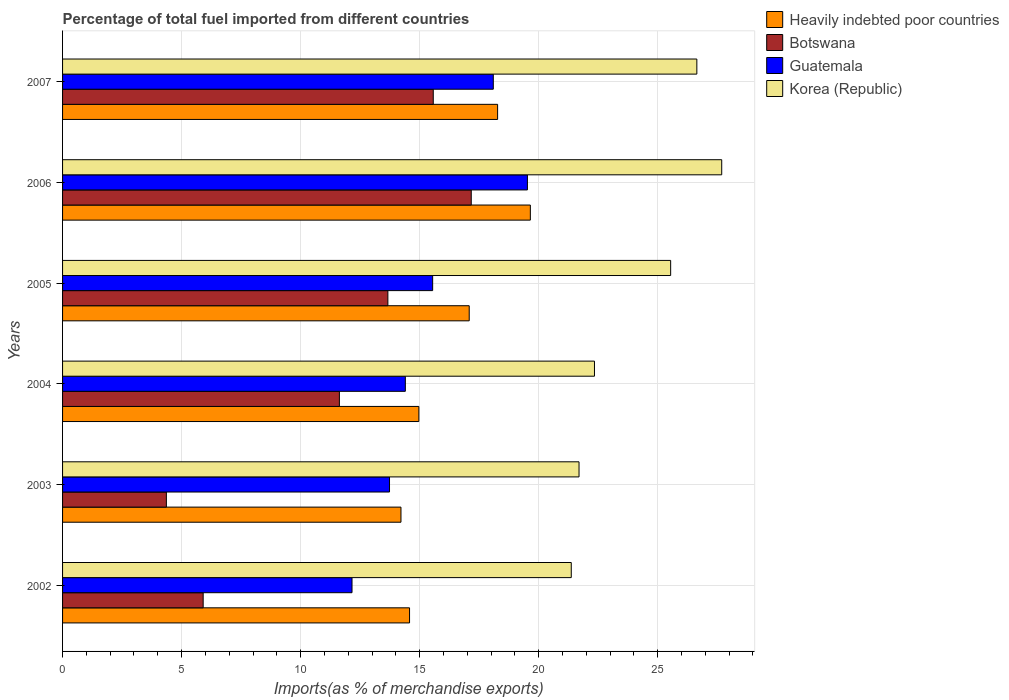Are the number of bars on each tick of the Y-axis equal?
Offer a terse response. Yes. How many bars are there on the 4th tick from the top?
Ensure brevity in your answer.  4. How many bars are there on the 3rd tick from the bottom?
Provide a succinct answer. 4. In how many cases, is the number of bars for a given year not equal to the number of legend labels?
Your response must be concise. 0. What is the percentage of imports to different countries in Guatemala in 2003?
Your response must be concise. 13.73. Across all years, what is the maximum percentage of imports to different countries in Heavily indebted poor countries?
Offer a terse response. 19.65. Across all years, what is the minimum percentage of imports to different countries in Korea (Republic)?
Offer a very short reply. 21.37. In which year was the percentage of imports to different countries in Guatemala maximum?
Provide a succinct answer. 2006. What is the total percentage of imports to different countries in Botswana in the graph?
Ensure brevity in your answer.  68.3. What is the difference between the percentage of imports to different countries in Korea (Republic) in 2002 and that in 2003?
Offer a terse response. -0.33. What is the difference between the percentage of imports to different countries in Botswana in 2005 and the percentage of imports to different countries in Korea (Republic) in 2007?
Offer a very short reply. -12.98. What is the average percentage of imports to different countries in Heavily indebted poor countries per year?
Keep it short and to the point. 16.46. In the year 2006, what is the difference between the percentage of imports to different countries in Korea (Republic) and percentage of imports to different countries in Guatemala?
Your response must be concise. 8.16. What is the ratio of the percentage of imports to different countries in Korea (Republic) in 2004 to that in 2005?
Provide a succinct answer. 0.87. What is the difference between the highest and the second highest percentage of imports to different countries in Guatemala?
Ensure brevity in your answer.  1.43. What is the difference between the highest and the lowest percentage of imports to different countries in Heavily indebted poor countries?
Your response must be concise. 5.44. In how many years, is the percentage of imports to different countries in Botswana greater than the average percentage of imports to different countries in Botswana taken over all years?
Your answer should be very brief. 4. Is the sum of the percentage of imports to different countries in Korea (Republic) in 2003 and 2006 greater than the maximum percentage of imports to different countries in Guatemala across all years?
Your answer should be compact. Yes. Is it the case that in every year, the sum of the percentage of imports to different countries in Guatemala and percentage of imports to different countries in Botswana is greater than the sum of percentage of imports to different countries in Korea (Republic) and percentage of imports to different countries in Heavily indebted poor countries?
Your answer should be compact. No. What does the 4th bar from the top in 2003 represents?
Provide a short and direct response. Heavily indebted poor countries. What does the 2nd bar from the bottom in 2006 represents?
Your answer should be compact. Botswana. Is it the case that in every year, the sum of the percentage of imports to different countries in Korea (Republic) and percentage of imports to different countries in Guatemala is greater than the percentage of imports to different countries in Heavily indebted poor countries?
Provide a succinct answer. Yes. How many bars are there?
Give a very brief answer. 24. How many years are there in the graph?
Offer a very short reply. 6. What is the difference between two consecutive major ticks on the X-axis?
Your answer should be very brief. 5. Are the values on the major ticks of X-axis written in scientific E-notation?
Your answer should be compact. No. Does the graph contain any zero values?
Make the answer very short. No. Does the graph contain grids?
Offer a very short reply. Yes. Where does the legend appear in the graph?
Keep it short and to the point. Top right. How many legend labels are there?
Your answer should be very brief. 4. How are the legend labels stacked?
Your answer should be compact. Vertical. What is the title of the graph?
Ensure brevity in your answer.  Percentage of total fuel imported from different countries. What is the label or title of the X-axis?
Your response must be concise. Imports(as % of merchandise exports). What is the Imports(as % of merchandise exports) in Heavily indebted poor countries in 2002?
Your answer should be compact. 14.58. What is the Imports(as % of merchandise exports) of Botswana in 2002?
Your answer should be very brief. 5.91. What is the Imports(as % of merchandise exports) in Guatemala in 2002?
Provide a succinct answer. 12.16. What is the Imports(as % of merchandise exports) in Korea (Republic) in 2002?
Ensure brevity in your answer.  21.37. What is the Imports(as % of merchandise exports) of Heavily indebted poor countries in 2003?
Offer a terse response. 14.21. What is the Imports(as % of merchandise exports) in Botswana in 2003?
Provide a short and direct response. 4.36. What is the Imports(as % of merchandise exports) in Guatemala in 2003?
Your answer should be very brief. 13.73. What is the Imports(as % of merchandise exports) in Korea (Republic) in 2003?
Your answer should be very brief. 21.69. What is the Imports(as % of merchandise exports) in Heavily indebted poor countries in 2004?
Your response must be concise. 14.97. What is the Imports(as % of merchandise exports) of Botswana in 2004?
Provide a succinct answer. 11.63. What is the Imports(as % of merchandise exports) in Guatemala in 2004?
Keep it short and to the point. 14.4. What is the Imports(as % of merchandise exports) in Korea (Republic) in 2004?
Offer a terse response. 22.34. What is the Imports(as % of merchandise exports) in Heavily indebted poor countries in 2005?
Provide a succinct answer. 17.08. What is the Imports(as % of merchandise exports) of Botswana in 2005?
Offer a very short reply. 13.66. What is the Imports(as % of merchandise exports) in Guatemala in 2005?
Your answer should be very brief. 15.55. What is the Imports(as % of merchandise exports) of Korea (Republic) in 2005?
Keep it short and to the point. 25.54. What is the Imports(as % of merchandise exports) in Heavily indebted poor countries in 2006?
Your answer should be very brief. 19.65. What is the Imports(as % of merchandise exports) in Botswana in 2006?
Provide a succinct answer. 17.17. What is the Imports(as % of merchandise exports) of Guatemala in 2006?
Give a very brief answer. 19.53. What is the Imports(as % of merchandise exports) in Korea (Republic) in 2006?
Your answer should be very brief. 27.69. What is the Imports(as % of merchandise exports) of Heavily indebted poor countries in 2007?
Offer a terse response. 18.27. What is the Imports(as % of merchandise exports) of Botswana in 2007?
Your response must be concise. 15.57. What is the Imports(as % of merchandise exports) in Guatemala in 2007?
Make the answer very short. 18.09. What is the Imports(as % of merchandise exports) in Korea (Republic) in 2007?
Provide a short and direct response. 26.64. Across all years, what is the maximum Imports(as % of merchandise exports) of Heavily indebted poor countries?
Provide a succinct answer. 19.65. Across all years, what is the maximum Imports(as % of merchandise exports) of Botswana?
Your response must be concise. 17.17. Across all years, what is the maximum Imports(as % of merchandise exports) of Guatemala?
Offer a very short reply. 19.53. Across all years, what is the maximum Imports(as % of merchandise exports) in Korea (Republic)?
Provide a succinct answer. 27.69. Across all years, what is the minimum Imports(as % of merchandise exports) of Heavily indebted poor countries?
Keep it short and to the point. 14.21. Across all years, what is the minimum Imports(as % of merchandise exports) of Botswana?
Give a very brief answer. 4.36. Across all years, what is the minimum Imports(as % of merchandise exports) in Guatemala?
Provide a short and direct response. 12.16. Across all years, what is the minimum Imports(as % of merchandise exports) in Korea (Republic)?
Your answer should be very brief. 21.37. What is the total Imports(as % of merchandise exports) in Heavily indebted poor countries in the graph?
Make the answer very short. 98.76. What is the total Imports(as % of merchandise exports) of Botswana in the graph?
Offer a terse response. 68.3. What is the total Imports(as % of merchandise exports) in Guatemala in the graph?
Offer a very short reply. 93.46. What is the total Imports(as % of merchandise exports) of Korea (Republic) in the graph?
Provide a short and direct response. 145.28. What is the difference between the Imports(as % of merchandise exports) in Heavily indebted poor countries in 2002 and that in 2003?
Provide a succinct answer. 0.36. What is the difference between the Imports(as % of merchandise exports) of Botswana in 2002 and that in 2003?
Provide a short and direct response. 1.55. What is the difference between the Imports(as % of merchandise exports) of Guatemala in 2002 and that in 2003?
Keep it short and to the point. -1.58. What is the difference between the Imports(as % of merchandise exports) of Korea (Republic) in 2002 and that in 2003?
Give a very brief answer. -0.33. What is the difference between the Imports(as % of merchandise exports) in Heavily indebted poor countries in 2002 and that in 2004?
Provide a short and direct response. -0.39. What is the difference between the Imports(as % of merchandise exports) of Botswana in 2002 and that in 2004?
Provide a short and direct response. -5.72. What is the difference between the Imports(as % of merchandise exports) in Guatemala in 2002 and that in 2004?
Your answer should be very brief. -2.24. What is the difference between the Imports(as % of merchandise exports) in Korea (Republic) in 2002 and that in 2004?
Your response must be concise. -0.97. What is the difference between the Imports(as % of merchandise exports) in Heavily indebted poor countries in 2002 and that in 2005?
Keep it short and to the point. -2.51. What is the difference between the Imports(as % of merchandise exports) of Botswana in 2002 and that in 2005?
Provide a succinct answer. -7.76. What is the difference between the Imports(as % of merchandise exports) in Guatemala in 2002 and that in 2005?
Give a very brief answer. -3.39. What is the difference between the Imports(as % of merchandise exports) in Korea (Republic) in 2002 and that in 2005?
Provide a succinct answer. -4.17. What is the difference between the Imports(as % of merchandise exports) in Heavily indebted poor countries in 2002 and that in 2006?
Offer a terse response. -5.07. What is the difference between the Imports(as % of merchandise exports) of Botswana in 2002 and that in 2006?
Your response must be concise. -11.26. What is the difference between the Imports(as % of merchandise exports) in Guatemala in 2002 and that in 2006?
Keep it short and to the point. -7.37. What is the difference between the Imports(as % of merchandise exports) of Korea (Republic) in 2002 and that in 2006?
Keep it short and to the point. -6.32. What is the difference between the Imports(as % of merchandise exports) of Heavily indebted poor countries in 2002 and that in 2007?
Ensure brevity in your answer.  -3.7. What is the difference between the Imports(as % of merchandise exports) in Botswana in 2002 and that in 2007?
Provide a short and direct response. -9.67. What is the difference between the Imports(as % of merchandise exports) in Guatemala in 2002 and that in 2007?
Give a very brief answer. -5.93. What is the difference between the Imports(as % of merchandise exports) of Korea (Republic) in 2002 and that in 2007?
Provide a short and direct response. -5.28. What is the difference between the Imports(as % of merchandise exports) of Heavily indebted poor countries in 2003 and that in 2004?
Your response must be concise. -0.75. What is the difference between the Imports(as % of merchandise exports) in Botswana in 2003 and that in 2004?
Make the answer very short. -7.27. What is the difference between the Imports(as % of merchandise exports) in Guatemala in 2003 and that in 2004?
Make the answer very short. -0.66. What is the difference between the Imports(as % of merchandise exports) of Korea (Republic) in 2003 and that in 2004?
Offer a very short reply. -0.65. What is the difference between the Imports(as % of merchandise exports) of Heavily indebted poor countries in 2003 and that in 2005?
Give a very brief answer. -2.87. What is the difference between the Imports(as % of merchandise exports) of Botswana in 2003 and that in 2005?
Provide a succinct answer. -9.3. What is the difference between the Imports(as % of merchandise exports) in Guatemala in 2003 and that in 2005?
Keep it short and to the point. -1.81. What is the difference between the Imports(as % of merchandise exports) in Korea (Republic) in 2003 and that in 2005?
Give a very brief answer. -3.85. What is the difference between the Imports(as % of merchandise exports) of Heavily indebted poor countries in 2003 and that in 2006?
Ensure brevity in your answer.  -5.43. What is the difference between the Imports(as % of merchandise exports) in Botswana in 2003 and that in 2006?
Offer a very short reply. -12.81. What is the difference between the Imports(as % of merchandise exports) in Guatemala in 2003 and that in 2006?
Provide a succinct answer. -5.79. What is the difference between the Imports(as % of merchandise exports) in Korea (Republic) in 2003 and that in 2006?
Your answer should be compact. -5.99. What is the difference between the Imports(as % of merchandise exports) of Heavily indebted poor countries in 2003 and that in 2007?
Offer a very short reply. -4.06. What is the difference between the Imports(as % of merchandise exports) of Botswana in 2003 and that in 2007?
Give a very brief answer. -11.21. What is the difference between the Imports(as % of merchandise exports) in Guatemala in 2003 and that in 2007?
Your answer should be very brief. -4.36. What is the difference between the Imports(as % of merchandise exports) of Korea (Republic) in 2003 and that in 2007?
Make the answer very short. -4.95. What is the difference between the Imports(as % of merchandise exports) of Heavily indebted poor countries in 2004 and that in 2005?
Offer a very short reply. -2.12. What is the difference between the Imports(as % of merchandise exports) of Botswana in 2004 and that in 2005?
Your answer should be compact. -2.04. What is the difference between the Imports(as % of merchandise exports) of Guatemala in 2004 and that in 2005?
Make the answer very short. -1.15. What is the difference between the Imports(as % of merchandise exports) in Korea (Republic) in 2004 and that in 2005?
Offer a very short reply. -3.2. What is the difference between the Imports(as % of merchandise exports) in Heavily indebted poor countries in 2004 and that in 2006?
Provide a succinct answer. -4.68. What is the difference between the Imports(as % of merchandise exports) of Botswana in 2004 and that in 2006?
Provide a short and direct response. -5.54. What is the difference between the Imports(as % of merchandise exports) in Guatemala in 2004 and that in 2006?
Offer a very short reply. -5.13. What is the difference between the Imports(as % of merchandise exports) in Korea (Republic) in 2004 and that in 2006?
Your answer should be very brief. -5.35. What is the difference between the Imports(as % of merchandise exports) in Heavily indebted poor countries in 2004 and that in 2007?
Offer a terse response. -3.31. What is the difference between the Imports(as % of merchandise exports) in Botswana in 2004 and that in 2007?
Provide a short and direct response. -3.94. What is the difference between the Imports(as % of merchandise exports) of Guatemala in 2004 and that in 2007?
Your response must be concise. -3.69. What is the difference between the Imports(as % of merchandise exports) in Korea (Republic) in 2004 and that in 2007?
Give a very brief answer. -4.3. What is the difference between the Imports(as % of merchandise exports) in Heavily indebted poor countries in 2005 and that in 2006?
Provide a succinct answer. -2.57. What is the difference between the Imports(as % of merchandise exports) in Botswana in 2005 and that in 2006?
Make the answer very short. -3.5. What is the difference between the Imports(as % of merchandise exports) of Guatemala in 2005 and that in 2006?
Your answer should be very brief. -3.98. What is the difference between the Imports(as % of merchandise exports) of Korea (Republic) in 2005 and that in 2006?
Your answer should be very brief. -2.15. What is the difference between the Imports(as % of merchandise exports) in Heavily indebted poor countries in 2005 and that in 2007?
Provide a short and direct response. -1.19. What is the difference between the Imports(as % of merchandise exports) of Botswana in 2005 and that in 2007?
Your response must be concise. -1.91. What is the difference between the Imports(as % of merchandise exports) of Guatemala in 2005 and that in 2007?
Your response must be concise. -2.55. What is the difference between the Imports(as % of merchandise exports) of Korea (Republic) in 2005 and that in 2007?
Ensure brevity in your answer.  -1.1. What is the difference between the Imports(as % of merchandise exports) of Heavily indebted poor countries in 2006 and that in 2007?
Your answer should be very brief. 1.38. What is the difference between the Imports(as % of merchandise exports) of Botswana in 2006 and that in 2007?
Offer a terse response. 1.6. What is the difference between the Imports(as % of merchandise exports) in Guatemala in 2006 and that in 2007?
Your answer should be compact. 1.43. What is the difference between the Imports(as % of merchandise exports) of Korea (Republic) in 2006 and that in 2007?
Ensure brevity in your answer.  1.04. What is the difference between the Imports(as % of merchandise exports) in Heavily indebted poor countries in 2002 and the Imports(as % of merchandise exports) in Botswana in 2003?
Your response must be concise. 10.21. What is the difference between the Imports(as % of merchandise exports) of Heavily indebted poor countries in 2002 and the Imports(as % of merchandise exports) of Guatemala in 2003?
Ensure brevity in your answer.  0.84. What is the difference between the Imports(as % of merchandise exports) in Heavily indebted poor countries in 2002 and the Imports(as % of merchandise exports) in Korea (Republic) in 2003?
Offer a terse response. -7.12. What is the difference between the Imports(as % of merchandise exports) in Botswana in 2002 and the Imports(as % of merchandise exports) in Guatemala in 2003?
Provide a succinct answer. -7.83. What is the difference between the Imports(as % of merchandise exports) in Botswana in 2002 and the Imports(as % of merchandise exports) in Korea (Republic) in 2003?
Offer a very short reply. -15.79. What is the difference between the Imports(as % of merchandise exports) in Guatemala in 2002 and the Imports(as % of merchandise exports) in Korea (Republic) in 2003?
Offer a very short reply. -9.54. What is the difference between the Imports(as % of merchandise exports) in Heavily indebted poor countries in 2002 and the Imports(as % of merchandise exports) in Botswana in 2004?
Offer a very short reply. 2.95. What is the difference between the Imports(as % of merchandise exports) of Heavily indebted poor countries in 2002 and the Imports(as % of merchandise exports) of Guatemala in 2004?
Your response must be concise. 0.18. What is the difference between the Imports(as % of merchandise exports) in Heavily indebted poor countries in 2002 and the Imports(as % of merchandise exports) in Korea (Republic) in 2004?
Provide a succinct answer. -7.77. What is the difference between the Imports(as % of merchandise exports) of Botswana in 2002 and the Imports(as % of merchandise exports) of Guatemala in 2004?
Offer a terse response. -8.49. What is the difference between the Imports(as % of merchandise exports) of Botswana in 2002 and the Imports(as % of merchandise exports) of Korea (Republic) in 2004?
Give a very brief answer. -16.44. What is the difference between the Imports(as % of merchandise exports) in Guatemala in 2002 and the Imports(as % of merchandise exports) in Korea (Republic) in 2004?
Provide a succinct answer. -10.18. What is the difference between the Imports(as % of merchandise exports) in Heavily indebted poor countries in 2002 and the Imports(as % of merchandise exports) in Botswana in 2005?
Keep it short and to the point. 0.91. What is the difference between the Imports(as % of merchandise exports) of Heavily indebted poor countries in 2002 and the Imports(as % of merchandise exports) of Guatemala in 2005?
Give a very brief answer. -0.97. What is the difference between the Imports(as % of merchandise exports) in Heavily indebted poor countries in 2002 and the Imports(as % of merchandise exports) in Korea (Republic) in 2005?
Provide a short and direct response. -10.97. What is the difference between the Imports(as % of merchandise exports) of Botswana in 2002 and the Imports(as % of merchandise exports) of Guatemala in 2005?
Your answer should be compact. -9.64. What is the difference between the Imports(as % of merchandise exports) of Botswana in 2002 and the Imports(as % of merchandise exports) of Korea (Republic) in 2005?
Provide a succinct answer. -19.64. What is the difference between the Imports(as % of merchandise exports) in Guatemala in 2002 and the Imports(as % of merchandise exports) in Korea (Republic) in 2005?
Provide a short and direct response. -13.38. What is the difference between the Imports(as % of merchandise exports) of Heavily indebted poor countries in 2002 and the Imports(as % of merchandise exports) of Botswana in 2006?
Your answer should be compact. -2.59. What is the difference between the Imports(as % of merchandise exports) in Heavily indebted poor countries in 2002 and the Imports(as % of merchandise exports) in Guatemala in 2006?
Make the answer very short. -4.95. What is the difference between the Imports(as % of merchandise exports) of Heavily indebted poor countries in 2002 and the Imports(as % of merchandise exports) of Korea (Republic) in 2006?
Your answer should be very brief. -13.11. What is the difference between the Imports(as % of merchandise exports) in Botswana in 2002 and the Imports(as % of merchandise exports) in Guatemala in 2006?
Your response must be concise. -13.62. What is the difference between the Imports(as % of merchandise exports) in Botswana in 2002 and the Imports(as % of merchandise exports) in Korea (Republic) in 2006?
Offer a terse response. -21.78. What is the difference between the Imports(as % of merchandise exports) in Guatemala in 2002 and the Imports(as % of merchandise exports) in Korea (Republic) in 2006?
Provide a short and direct response. -15.53. What is the difference between the Imports(as % of merchandise exports) of Heavily indebted poor countries in 2002 and the Imports(as % of merchandise exports) of Botswana in 2007?
Your answer should be compact. -1. What is the difference between the Imports(as % of merchandise exports) in Heavily indebted poor countries in 2002 and the Imports(as % of merchandise exports) in Guatemala in 2007?
Make the answer very short. -3.52. What is the difference between the Imports(as % of merchandise exports) in Heavily indebted poor countries in 2002 and the Imports(as % of merchandise exports) in Korea (Republic) in 2007?
Offer a terse response. -12.07. What is the difference between the Imports(as % of merchandise exports) of Botswana in 2002 and the Imports(as % of merchandise exports) of Guatemala in 2007?
Offer a terse response. -12.19. What is the difference between the Imports(as % of merchandise exports) of Botswana in 2002 and the Imports(as % of merchandise exports) of Korea (Republic) in 2007?
Provide a short and direct response. -20.74. What is the difference between the Imports(as % of merchandise exports) of Guatemala in 2002 and the Imports(as % of merchandise exports) of Korea (Republic) in 2007?
Your response must be concise. -14.49. What is the difference between the Imports(as % of merchandise exports) in Heavily indebted poor countries in 2003 and the Imports(as % of merchandise exports) in Botswana in 2004?
Offer a terse response. 2.59. What is the difference between the Imports(as % of merchandise exports) in Heavily indebted poor countries in 2003 and the Imports(as % of merchandise exports) in Guatemala in 2004?
Your answer should be compact. -0.18. What is the difference between the Imports(as % of merchandise exports) in Heavily indebted poor countries in 2003 and the Imports(as % of merchandise exports) in Korea (Republic) in 2004?
Give a very brief answer. -8.13. What is the difference between the Imports(as % of merchandise exports) in Botswana in 2003 and the Imports(as % of merchandise exports) in Guatemala in 2004?
Give a very brief answer. -10.04. What is the difference between the Imports(as % of merchandise exports) of Botswana in 2003 and the Imports(as % of merchandise exports) of Korea (Republic) in 2004?
Offer a terse response. -17.98. What is the difference between the Imports(as % of merchandise exports) of Guatemala in 2003 and the Imports(as % of merchandise exports) of Korea (Republic) in 2004?
Your answer should be compact. -8.61. What is the difference between the Imports(as % of merchandise exports) of Heavily indebted poor countries in 2003 and the Imports(as % of merchandise exports) of Botswana in 2005?
Keep it short and to the point. 0.55. What is the difference between the Imports(as % of merchandise exports) in Heavily indebted poor countries in 2003 and the Imports(as % of merchandise exports) in Guatemala in 2005?
Offer a very short reply. -1.33. What is the difference between the Imports(as % of merchandise exports) of Heavily indebted poor countries in 2003 and the Imports(as % of merchandise exports) of Korea (Republic) in 2005?
Provide a succinct answer. -11.33. What is the difference between the Imports(as % of merchandise exports) of Botswana in 2003 and the Imports(as % of merchandise exports) of Guatemala in 2005?
Offer a terse response. -11.19. What is the difference between the Imports(as % of merchandise exports) of Botswana in 2003 and the Imports(as % of merchandise exports) of Korea (Republic) in 2005?
Provide a short and direct response. -21.18. What is the difference between the Imports(as % of merchandise exports) in Guatemala in 2003 and the Imports(as % of merchandise exports) in Korea (Republic) in 2005?
Provide a succinct answer. -11.81. What is the difference between the Imports(as % of merchandise exports) in Heavily indebted poor countries in 2003 and the Imports(as % of merchandise exports) in Botswana in 2006?
Make the answer very short. -2.95. What is the difference between the Imports(as % of merchandise exports) in Heavily indebted poor countries in 2003 and the Imports(as % of merchandise exports) in Guatemala in 2006?
Provide a short and direct response. -5.31. What is the difference between the Imports(as % of merchandise exports) of Heavily indebted poor countries in 2003 and the Imports(as % of merchandise exports) of Korea (Republic) in 2006?
Offer a terse response. -13.47. What is the difference between the Imports(as % of merchandise exports) of Botswana in 2003 and the Imports(as % of merchandise exports) of Guatemala in 2006?
Offer a terse response. -15.17. What is the difference between the Imports(as % of merchandise exports) of Botswana in 2003 and the Imports(as % of merchandise exports) of Korea (Republic) in 2006?
Provide a succinct answer. -23.33. What is the difference between the Imports(as % of merchandise exports) of Guatemala in 2003 and the Imports(as % of merchandise exports) of Korea (Republic) in 2006?
Your response must be concise. -13.95. What is the difference between the Imports(as % of merchandise exports) of Heavily indebted poor countries in 2003 and the Imports(as % of merchandise exports) of Botswana in 2007?
Your answer should be compact. -1.36. What is the difference between the Imports(as % of merchandise exports) of Heavily indebted poor countries in 2003 and the Imports(as % of merchandise exports) of Guatemala in 2007?
Your answer should be compact. -3.88. What is the difference between the Imports(as % of merchandise exports) of Heavily indebted poor countries in 2003 and the Imports(as % of merchandise exports) of Korea (Republic) in 2007?
Your response must be concise. -12.43. What is the difference between the Imports(as % of merchandise exports) in Botswana in 2003 and the Imports(as % of merchandise exports) in Guatemala in 2007?
Provide a short and direct response. -13.73. What is the difference between the Imports(as % of merchandise exports) in Botswana in 2003 and the Imports(as % of merchandise exports) in Korea (Republic) in 2007?
Keep it short and to the point. -22.28. What is the difference between the Imports(as % of merchandise exports) in Guatemala in 2003 and the Imports(as % of merchandise exports) in Korea (Republic) in 2007?
Offer a terse response. -12.91. What is the difference between the Imports(as % of merchandise exports) in Heavily indebted poor countries in 2004 and the Imports(as % of merchandise exports) in Botswana in 2005?
Your answer should be compact. 1.3. What is the difference between the Imports(as % of merchandise exports) of Heavily indebted poor countries in 2004 and the Imports(as % of merchandise exports) of Guatemala in 2005?
Offer a terse response. -0.58. What is the difference between the Imports(as % of merchandise exports) in Heavily indebted poor countries in 2004 and the Imports(as % of merchandise exports) in Korea (Republic) in 2005?
Provide a short and direct response. -10.58. What is the difference between the Imports(as % of merchandise exports) in Botswana in 2004 and the Imports(as % of merchandise exports) in Guatemala in 2005?
Your response must be concise. -3.92. What is the difference between the Imports(as % of merchandise exports) in Botswana in 2004 and the Imports(as % of merchandise exports) in Korea (Republic) in 2005?
Offer a very short reply. -13.91. What is the difference between the Imports(as % of merchandise exports) of Guatemala in 2004 and the Imports(as % of merchandise exports) of Korea (Republic) in 2005?
Make the answer very short. -11.14. What is the difference between the Imports(as % of merchandise exports) in Heavily indebted poor countries in 2004 and the Imports(as % of merchandise exports) in Botswana in 2006?
Your answer should be very brief. -2.2. What is the difference between the Imports(as % of merchandise exports) of Heavily indebted poor countries in 2004 and the Imports(as % of merchandise exports) of Guatemala in 2006?
Keep it short and to the point. -4.56. What is the difference between the Imports(as % of merchandise exports) in Heavily indebted poor countries in 2004 and the Imports(as % of merchandise exports) in Korea (Republic) in 2006?
Make the answer very short. -12.72. What is the difference between the Imports(as % of merchandise exports) in Botswana in 2004 and the Imports(as % of merchandise exports) in Guatemala in 2006?
Your answer should be very brief. -7.9. What is the difference between the Imports(as % of merchandise exports) in Botswana in 2004 and the Imports(as % of merchandise exports) in Korea (Republic) in 2006?
Your answer should be very brief. -16.06. What is the difference between the Imports(as % of merchandise exports) in Guatemala in 2004 and the Imports(as % of merchandise exports) in Korea (Republic) in 2006?
Keep it short and to the point. -13.29. What is the difference between the Imports(as % of merchandise exports) of Heavily indebted poor countries in 2004 and the Imports(as % of merchandise exports) of Botswana in 2007?
Provide a succinct answer. -0.6. What is the difference between the Imports(as % of merchandise exports) of Heavily indebted poor countries in 2004 and the Imports(as % of merchandise exports) of Guatemala in 2007?
Your answer should be compact. -3.13. What is the difference between the Imports(as % of merchandise exports) in Heavily indebted poor countries in 2004 and the Imports(as % of merchandise exports) in Korea (Republic) in 2007?
Ensure brevity in your answer.  -11.68. What is the difference between the Imports(as % of merchandise exports) in Botswana in 2004 and the Imports(as % of merchandise exports) in Guatemala in 2007?
Offer a terse response. -6.46. What is the difference between the Imports(as % of merchandise exports) in Botswana in 2004 and the Imports(as % of merchandise exports) in Korea (Republic) in 2007?
Ensure brevity in your answer.  -15.02. What is the difference between the Imports(as % of merchandise exports) of Guatemala in 2004 and the Imports(as % of merchandise exports) of Korea (Republic) in 2007?
Your answer should be compact. -12.25. What is the difference between the Imports(as % of merchandise exports) in Heavily indebted poor countries in 2005 and the Imports(as % of merchandise exports) in Botswana in 2006?
Offer a very short reply. -0.09. What is the difference between the Imports(as % of merchandise exports) in Heavily indebted poor countries in 2005 and the Imports(as % of merchandise exports) in Guatemala in 2006?
Make the answer very short. -2.44. What is the difference between the Imports(as % of merchandise exports) of Heavily indebted poor countries in 2005 and the Imports(as % of merchandise exports) of Korea (Republic) in 2006?
Offer a very short reply. -10.61. What is the difference between the Imports(as % of merchandise exports) in Botswana in 2005 and the Imports(as % of merchandise exports) in Guatemala in 2006?
Give a very brief answer. -5.86. What is the difference between the Imports(as % of merchandise exports) in Botswana in 2005 and the Imports(as % of merchandise exports) in Korea (Republic) in 2006?
Provide a succinct answer. -14.02. What is the difference between the Imports(as % of merchandise exports) in Guatemala in 2005 and the Imports(as % of merchandise exports) in Korea (Republic) in 2006?
Your answer should be compact. -12.14. What is the difference between the Imports(as % of merchandise exports) in Heavily indebted poor countries in 2005 and the Imports(as % of merchandise exports) in Botswana in 2007?
Ensure brevity in your answer.  1.51. What is the difference between the Imports(as % of merchandise exports) of Heavily indebted poor countries in 2005 and the Imports(as % of merchandise exports) of Guatemala in 2007?
Provide a short and direct response. -1.01. What is the difference between the Imports(as % of merchandise exports) in Heavily indebted poor countries in 2005 and the Imports(as % of merchandise exports) in Korea (Republic) in 2007?
Offer a terse response. -9.56. What is the difference between the Imports(as % of merchandise exports) of Botswana in 2005 and the Imports(as % of merchandise exports) of Guatemala in 2007?
Offer a very short reply. -4.43. What is the difference between the Imports(as % of merchandise exports) in Botswana in 2005 and the Imports(as % of merchandise exports) in Korea (Republic) in 2007?
Your answer should be very brief. -12.98. What is the difference between the Imports(as % of merchandise exports) of Guatemala in 2005 and the Imports(as % of merchandise exports) of Korea (Republic) in 2007?
Provide a short and direct response. -11.1. What is the difference between the Imports(as % of merchandise exports) of Heavily indebted poor countries in 2006 and the Imports(as % of merchandise exports) of Botswana in 2007?
Offer a terse response. 4.08. What is the difference between the Imports(as % of merchandise exports) in Heavily indebted poor countries in 2006 and the Imports(as % of merchandise exports) in Guatemala in 2007?
Offer a terse response. 1.56. What is the difference between the Imports(as % of merchandise exports) of Heavily indebted poor countries in 2006 and the Imports(as % of merchandise exports) of Korea (Republic) in 2007?
Your answer should be very brief. -6.99. What is the difference between the Imports(as % of merchandise exports) in Botswana in 2006 and the Imports(as % of merchandise exports) in Guatemala in 2007?
Your response must be concise. -0.93. What is the difference between the Imports(as % of merchandise exports) of Botswana in 2006 and the Imports(as % of merchandise exports) of Korea (Republic) in 2007?
Provide a short and direct response. -9.48. What is the difference between the Imports(as % of merchandise exports) in Guatemala in 2006 and the Imports(as % of merchandise exports) in Korea (Republic) in 2007?
Your answer should be compact. -7.12. What is the average Imports(as % of merchandise exports) of Heavily indebted poor countries per year?
Your response must be concise. 16.46. What is the average Imports(as % of merchandise exports) in Botswana per year?
Provide a short and direct response. 11.38. What is the average Imports(as % of merchandise exports) of Guatemala per year?
Offer a very short reply. 15.58. What is the average Imports(as % of merchandise exports) of Korea (Republic) per year?
Provide a short and direct response. 24.21. In the year 2002, what is the difference between the Imports(as % of merchandise exports) of Heavily indebted poor countries and Imports(as % of merchandise exports) of Botswana?
Your response must be concise. 8.67. In the year 2002, what is the difference between the Imports(as % of merchandise exports) in Heavily indebted poor countries and Imports(as % of merchandise exports) in Guatemala?
Provide a short and direct response. 2.42. In the year 2002, what is the difference between the Imports(as % of merchandise exports) of Heavily indebted poor countries and Imports(as % of merchandise exports) of Korea (Republic)?
Your answer should be compact. -6.79. In the year 2002, what is the difference between the Imports(as % of merchandise exports) in Botswana and Imports(as % of merchandise exports) in Guatemala?
Make the answer very short. -6.25. In the year 2002, what is the difference between the Imports(as % of merchandise exports) in Botswana and Imports(as % of merchandise exports) in Korea (Republic)?
Your answer should be very brief. -15.46. In the year 2002, what is the difference between the Imports(as % of merchandise exports) in Guatemala and Imports(as % of merchandise exports) in Korea (Republic)?
Make the answer very short. -9.21. In the year 2003, what is the difference between the Imports(as % of merchandise exports) of Heavily indebted poor countries and Imports(as % of merchandise exports) of Botswana?
Give a very brief answer. 9.85. In the year 2003, what is the difference between the Imports(as % of merchandise exports) in Heavily indebted poor countries and Imports(as % of merchandise exports) in Guatemala?
Make the answer very short. 0.48. In the year 2003, what is the difference between the Imports(as % of merchandise exports) in Heavily indebted poor countries and Imports(as % of merchandise exports) in Korea (Republic)?
Offer a terse response. -7.48. In the year 2003, what is the difference between the Imports(as % of merchandise exports) in Botswana and Imports(as % of merchandise exports) in Guatemala?
Keep it short and to the point. -9.37. In the year 2003, what is the difference between the Imports(as % of merchandise exports) of Botswana and Imports(as % of merchandise exports) of Korea (Republic)?
Give a very brief answer. -17.33. In the year 2003, what is the difference between the Imports(as % of merchandise exports) in Guatemala and Imports(as % of merchandise exports) in Korea (Republic)?
Your answer should be very brief. -7.96. In the year 2004, what is the difference between the Imports(as % of merchandise exports) of Heavily indebted poor countries and Imports(as % of merchandise exports) of Botswana?
Offer a very short reply. 3.34. In the year 2004, what is the difference between the Imports(as % of merchandise exports) of Heavily indebted poor countries and Imports(as % of merchandise exports) of Guatemala?
Give a very brief answer. 0.57. In the year 2004, what is the difference between the Imports(as % of merchandise exports) in Heavily indebted poor countries and Imports(as % of merchandise exports) in Korea (Republic)?
Your response must be concise. -7.38. In the year 2004, what is the difference between the Imports(as % of merchandise exports) of Botswana and Imports(as % of merchandise exports) of Guatemala?
Your response must be concise. -2.77. In the year 2004, what is the difference between the Imports(as % of merchandise exports) in Botswana and Imports(as % of merchandise exports) in Korea (Republic)?
Your response must be concise. -10.71. In the year 2004, what is the difference between the Imports(as % of merchandise exports) of Guatemala and Imports(as % of merchandise exports) of Korea (Republic)?
Provide a succinct answer. -7.94. In the year 2005, what is the difference between the Imports(as % of merchandise exports) of Heavily indebted poor countries and Imports(as % of merchandise exports) of Botswana?
Your response must be concise. 3.42. In the year 2005, what is the difference between the Imports(as % of merchandise exports) in Heavily indebted poor countries and Imports(as % of merchandise exports) in Guatemala?
Provide a short and direct response. 1.54. In the year 2005, what is the difference between the Imports(as % of merchandise exports) in Heavily indebted poor countries and Imports(as % of merchandise exports) in Korea (Republic)?
Offer a terse response. -8.46. In the year 2005, what is the difference between the Imports(as % of merchandise exports) in Botswana and Imports(as % of merchandise exports) in Guatemala?
Make the answer very short. -1.88. In the year 2005, what is the difference between the Imports(as % of merchandise exports) in Botswana and Imports(as % of merchandise exports) in Korea (Republic)?
Offer a terse response. -11.88. In the year 2005, what is the difference between the Imports(as % of merchandise exports) in Guatemala and Imports(as % of merchandise exports) in Korea (Republic)?
Provide a succinct answer. -10. In the year 2006, what is the difference between the Imports(as % of merchandise exports) in Heavily indebted poor countries and Imports(as % of merchandise exports) in Botswana?
Your response must be concise. 2.48. In the year 2006, what is the difference between the Imports(as % of merchandise exports) of Heavily indebted poor countries and Imports(as % of merchandise exports) of Guatemala?
Your answer should be compact. 0.12. In the year 2006, what is the difference between the Imports(as % of merchandise exports) in Heavily indebted poor countries and Imports(as % of merchandise exports) in Korea (Republic)?
Provide a short and direct response. -8.04. In the year 2006, what is the difference between the Imports(as % of merchandise exports) of Botswana and Imports(as % of merchandise exports) of Guatemala?
Make the answer very short. -2.36. In the year 2006, what is the difference between the Imports(as % of merchandise exports) in Botswana and Imports(as % of merchandise exports) in Korea (Republic)?
Your answer should be very brief. -10.52. In the year 2006, what is the difference between the Imports(as % of merchandise exports) of Guatemala and Imports(as % of merchandise exports) of Korea (Republic)?
Offer a very short reply. -8.16. In the year 2007, what is the difference between the Imports(as % of merchandise exports) of Heavily indebted poor countries and Imports(as % of merchandise exports) of Botswana?
Make the answer very short. 2.7. In the year 2007, what is the difference between the Imports(as % of merchandise exports) in Heavily indebted poor countries and Imports(as % of merchandise exports) in Guatemala?
Offer a very short reply. 0.18. In the year 2007, what is the difference between the Imports(as % of merchandise exports) of Heavily indebted poor countries and Imports(as % of merchandise exports) of Korea (Republic)?
Offer a very short reply. -8.37. In the year 2007, what is the difference between the Imports(as % of merchandise exports) of Botswana and Imports(as % of merchandise exports) of Guatemala?
Keep it short and to the point. -2.52. In the year 2007, what is the difference between the Imports(as % of merchandise exports) in Botswana and Imports(as % of merchandise exports) in Korea (Republic)?
Keep it short and to the point. -11.07. In the year 2007, what is the difference between the Imports(as % of merchandise exports) in Guatemala and Imports(as % of merchandise exports) in Korea (Republic)?
Keep it short and to the point. -8.55. What is the ratio of the Imports(as % of merchandise exports) in Heavily indebted poor countries in 2002 to that in 2003?
Provide a succinct answer. 1.03. What is the ratio of the Imports(as % of merchandise exports) in Botswana in 2002 to that in 2003?
Keep it short and to the point. 1.35. What is the ratio of the Imports(as % of merchandise exports) of Guatemala in 2002 to that in 2003?
Your answer should be compact. 0.89. What is the ratio of the Imports(as % of merchandise exports) of Korea (Republic) in 2002 to that in 2003?
Offer a very short reply. 0.98. What is the ratio of the Imports(as % of merchandise exports) in Heavily indebted poor countries in 2002 to that in 2004?
Keep it short and to the point. 0.97. What is the ratio of the Imports(as % of merchandise exports) of Botswana in 2002 to that in 2004?
Provide a short and direct response. 0.51. What is the ratio of the Imports(as % of merchandise exports) of Guatemala in 2002 to that in 2004?
Make the answer very short. 0.84. What is the ratio of the Imports(as % of merchandise exports) in Korea (Republic) in 2002 to that in 2004?
Your answer should be very brief. 0.96. What is the ratio of the Imports(as % of merchandise exports) in Heavily indebted poor countries in 2002 to that in 2005?
Offer a very short reply. 0.85. What is the ratio of the Imports(as % of merchandise exports) in Botswana in 2002 to that in 2005?
Give a very brief answer. 0.43. What is the ratio of the Imports(as % of merchandise exports) of Guatemala in 2002 to that in 2005?
Your response must be concise. 0.78. What is the ratio of the Imports(as % of merchandise exports) in Korea (Republic) in 2002 to that in 2005?
Offer a very short reply. 0.84. What is the ratio of the Imports(as % of merchandise exports) in Heavily indebted poor countries in 2002 to that in 2006?
Give a very brief answer. 0.74. What is the ratio of the Imports(as % of merchandise exports) in Botswana in 2002 to that in 2006?
Your response must be concise. 0.34. What is the ratio of the Imports(as % of merchandise exports) of Guatemala in 2002 to that in 2006?
Offer a terse response. 0.62. What is the ratio of the Imports(as % of merchandise exports) in Korea (Republic) in 2002 to that in 2006?
Offer a very short reply. 0.77. What is the ratio of the Imports(as % of merchandise exports) in Heavily indebted poor countries in 2002 to that in 2007?
Your answer should be very brief. 0.8. What is the ratio of the Imports(as % of merchandise exports) of Botswana in 2002 to that in 2007?
Offer a very short reply. 0.38. What is the ratio of the Imports(as % of merchandise exports) in Guatemala in 2002 to that in 2007?
Offer a very short reply. 0.67. What is the ratio of the Imports(as % of merchandise exports) of Korea (Republic) in 2002 to that in 2007?
Provide a succinct answer. 0.8. What is the ratio of the Imports(as % of merchandise exports) in Heavily indebted poor countries in 2003 to that in 2004?
Your answer should be very brief. 0.95. What is the ratio of the Imports(as % of merchandise exports) in Guatemala in 2003 to that in 2004?
Your answer should be compact. 0.95. What is the ratio of the Imports(as % of merchandise exports) in Heavily indebted poor countries in 2003 to that in 2005?
Provide a succinct answer. 0.83. What is the ratio of the Imports(as % of merchandise exports) in Botswana in 2003 to that in 2005?
Keep it short and to the point. 0.32. What is the ratio of the Imports(as % of merchandise exports) of Guatemala in 2003 to that in 2005?
Offer a very short reply. 0.88. What is the ratio of the Imports(as % of merchandise exports) of Korea (Republic) in 2003 to that in 2005?
Your answer should be compact. 0.85. What is the ratio of the Imports(as % of merchandise exports) in Heavily indebted poor countries in 2003 to that in 2006?
Provide a succinct answer. 0.72. What is the ratio of the Imports(as % of merchandise exports) of Botswana in 2003 to that in 2006?
Ensure brevity in your answer.  0.25. What is the ratio of the Imports(as % of merchandise exports) in Guatemala in 2003 to that in 2006?
Your answer should be very brief. 0.7. What is the ratio of the Imports(as % of merchandise exports) of Korea (Republic) in 2003 to that in 2006?
Make the answer very short. 0.78. What is the ratio of the Imports(as % of merchandise exports) in Botswana in 2003 to that in 2007?
Make the answer very short. 0.28. What is the ratio of the Imports(as % of merchandise exports) of Guatemala in 2003 to that in 2007?
Give a very brief answer. 0.76. What is the ratio of the Imports(as % of merchandise exports) in Korea (Republic) in 2003 to that in 2007?
Keep it short and to the point. 0.81. What is the ratio of the Imports(as % of merchandise exports) in Heavily indebted poor countries in 2004 to that in 2005?
Your response must be concise. 0.88. What is the ratio of the Imports(as % of merchandise exports) of Botswana in 2004 to that in 2005?
Make the answer very short. 0.85. What is the ratio of the Imports(as % of merchandise exports) in Guatemala in 2004 to that in 2005?
Make the answer very short. 0.93. What is the ratio of the Imports(as % of merchandise exports) of Korea (Republic) in 2004 to that in 2005?
Keep it short and to the point. 0.87. What is the ratio of the Imports(as % of merchandise exports) in Heavily indebted poor countries in 2004 to that in 2006?
Your response must be concise. 0.76. What is the ratio of the Imports(as % of merchandise exports) in Botswana in 2004 to that in 2006?
Make the answer very short. 0.68. What is the ratio of the Imports(as % of merchandise exports) of Guatemala in 2004 to that in 2006?
Keep it short and to the point. 0.74. What is the ratio of the Imports(as % of merchandise exports) in Korea (Republic) in 2004 to that in 2006?
Ensure brevity in your answer.  0.81. What is the ratio of the Imports(as % of merchandise exports) in Heavily indebted poor countries in 2004 to that in 2007?
Offer a very short reply. 0.82. What is the ratio of the Imports(as % of merchandise exports) of Botswana in 2004 to that in 2007?
Make the answer very short. 0.75. What is the ratio of the Imports(as % of merchandise exports) of Guatemala in 2004 to that in 2007?
Ensure brevity in your answer.  0.8. What is the ratio of the Imports(as % of merchandise exports) of Korea (Republic) in 2004 to that in 2007?
Keep it short and to the point. 0.84. What is the ratio of the Imports(as % of merchandise exports) in Heavily indebted poor countries in 2005 to that in 2006?
Give a very brief answer. 0.87. What is the ratio of the Imports(as % of merchandise exports) in Botswana in 2005 to that in 2006?
Your answer should be compact. 0.8. What is the ratio of the Imports(as % of merchandise exports) of Guatemala in 2005 to that in 2006?
Provide a short and direct response. 0.8. What is the ratio of the Imports(as % of merchandise exports) in Korea (Republic) in 2005 to that in 2006?
Offer a terse response. 0.92. What is the ratio of the Imports(as % of merchandise exports) of Heavily indebted poor countries in 2005 to that in 2007?
Provide a succinct answer. 0.93. What is the ratio of the Imports(as % of merchandise exports) in Botswana in 2005 to that in 2007?
Offer a terse response. 0.88. What is the ratio of the Imports(as % of merchandise exports) of Guatemala in 2005 to that in 2007?
Ensure brevity in your answer.  0.86. What is the ratio of the Imports(as % of merchandise exports) of Korea (Republic) in 2005 to that in 2007?
Your response must be concise. 0.96. What is the ratio of the Imports(as % of merchandise exports) in Heavily indebted poor countries in 2006 to that in 2007?
Provide a short and direct response. 1.08. What is the ratio of the Imports(as % of merchandise exports) of Botswana in 2006 to that in 2007?
Offer a terse response. 1.1. What is the ratio of the Imports(as % of merchandise exports) of Guatemala in 2006 to that in 2007?
Offer a terse response. 1.08. What is the ratio of the Imports(as % of merchandise exports) in Korea (Republic) in 2006 to that in 2007?
Offer a very short reply. 1.04. What is the difference between the highest and the second highest Imports(as % of merchandise exports) of Heavily indebted poor countries?
Your response must be concise. 1.38. What is the difference between the highest and the second highest Imports(as % of merchandise exports) in Botswana?
Ensure brevity in your answer.  1.6. What is the difference between the highest and the second highest Imports(as % of merchandise exports) of Guatemala?
Provide a short and direct response. 1.43. What is the difference between the highest and the second highest Imports(as % of merchandise exports) in Korea (Republic)?
Keep it short and to the point. 1.04. What is the difference between the highest and the lowest Imports(as % of merchandise exports) in Heavily indebted poor countries?
Keep it short and to the point. 5.43. What is the difference between the highest and the lowest Imports(as % of merchandise exports) of Botswana?
Your answer should be very brief. 12.81. What is the difference between the highest and the lowest Imports(as % of merchandise exports) of Guatemala?
Make the answer very short. 7.37. What is the difference between the highest and the lowest Imports(as % of merchandise exports) in Korea (Republic)?
Your response must be concise. 6.32. 